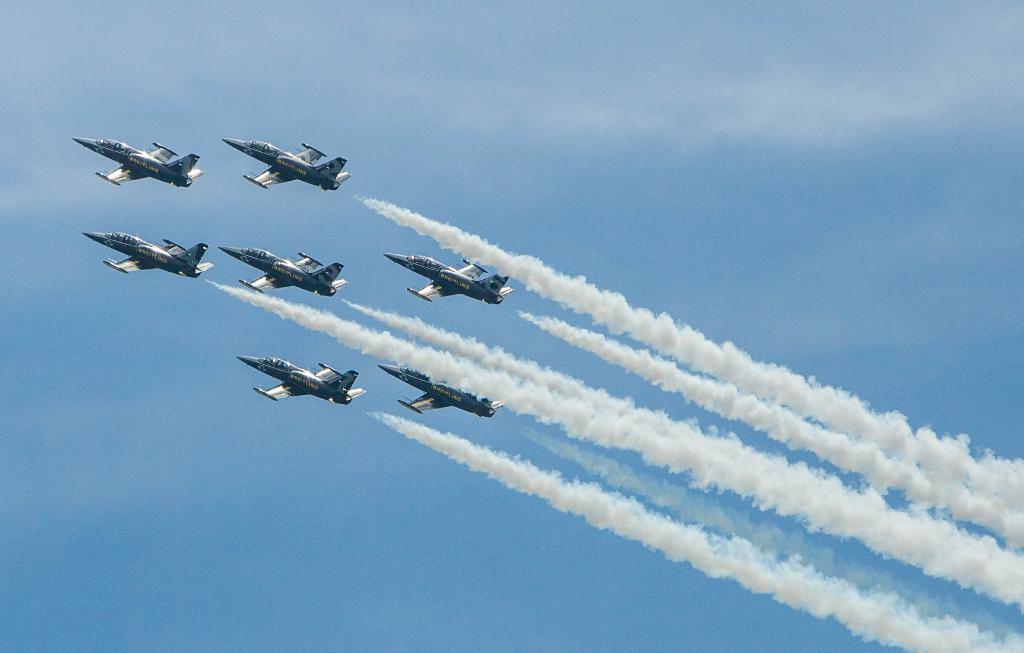In one or two sentences, can you explain what this image depicts? In this image I can see few jet planes which are blue and white in color are flying in the air. I can see smoke behind them. In the background I can see the sky. 